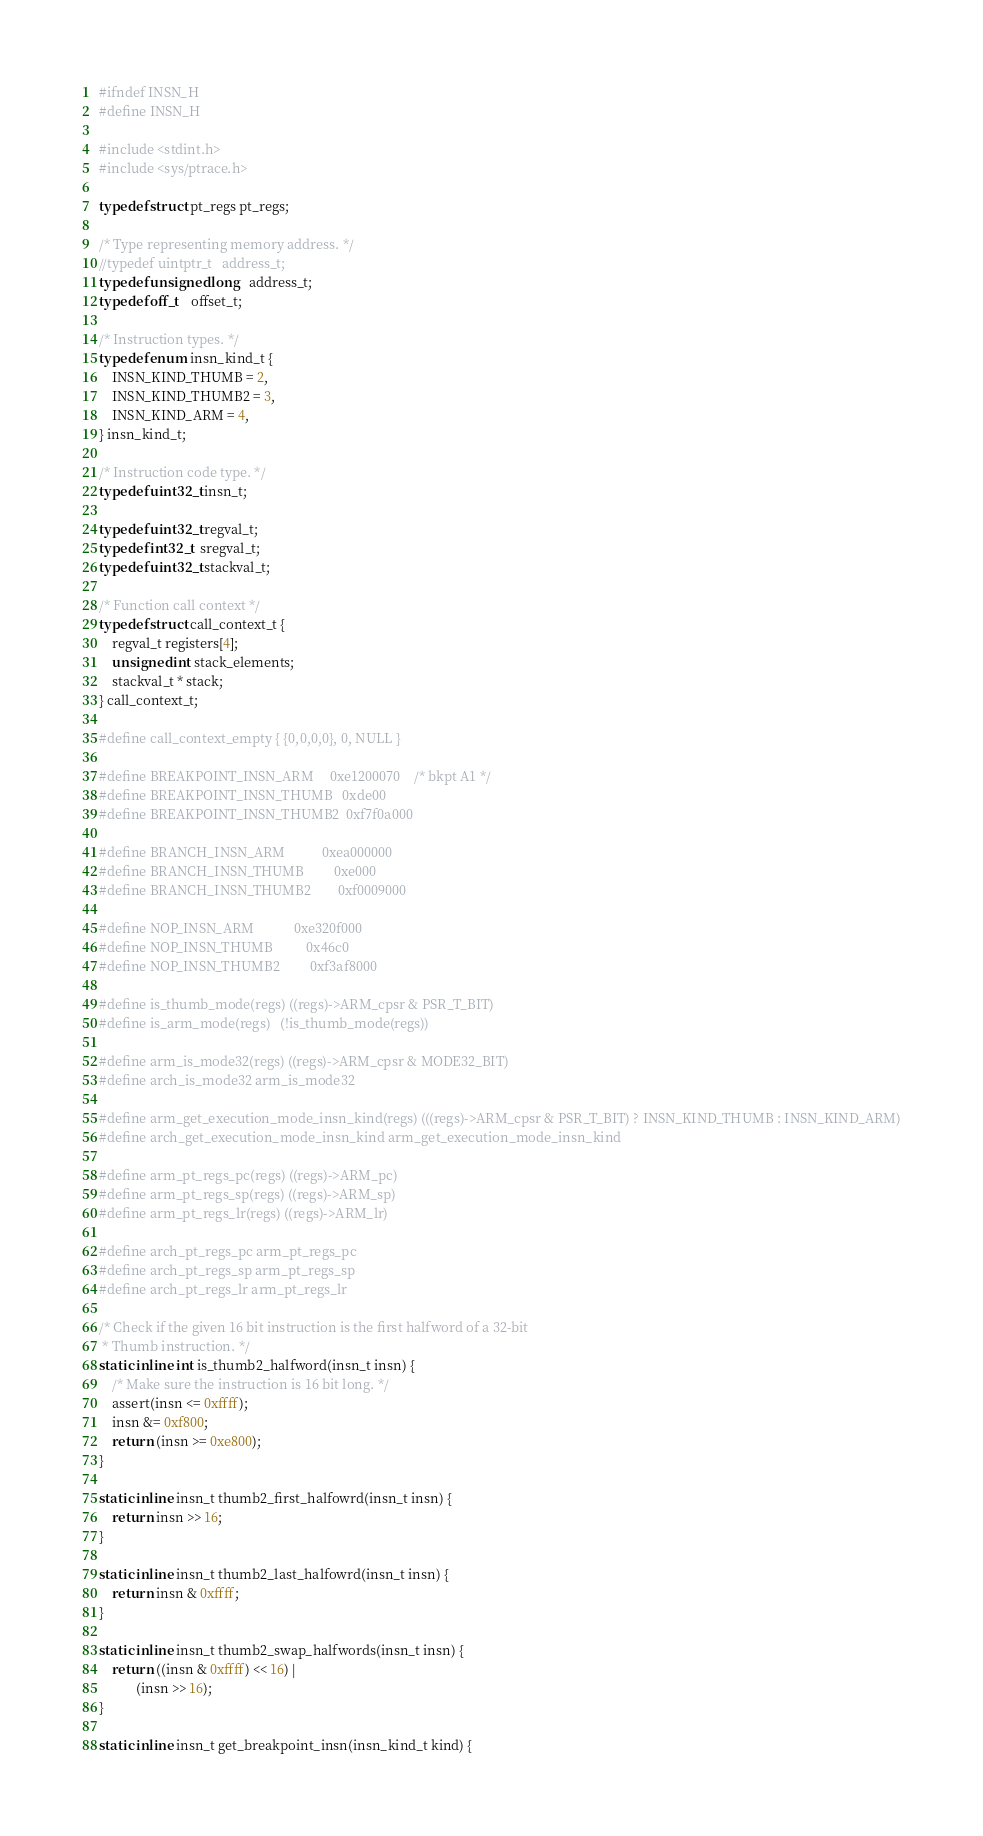<code> <loc_0><loc_0><loc_500><loc_500><_C_>#ifndef INSN_H
#define INSN_H

#include <stdint.h>
#include <sys/ptrace.h>

typedef struct pt_regs pt_regs;

/* Type representing memory address. */
//typedef uintptr_t   address_t;
typedef unsigned long   address_t;
typedef off_t    offset_t;

/* Instruction types. */
typedef enum insn_kind_t {
    INSN_KIND_THUMB = 2,
    INSN_KIND_THUMB2 = 3,
    INSN_KIND_ARM = 4,
} insn_kind_t;

/* Instruction code type. */
typedef uint32_t insn_t;

typedef uint32_t regval_t;
typedef int32_t  sregval_t;
typedef uint32_t stackval_t;

/* Function call context */
typedef struct call_context_t {
    regval_t registers[4];
    unsigned int stack_elements;
    stackval_t * stack;
} call_context_t;

#define call_context_empty { {0,0,0,0}, 0, NULL }

#define BREAKPOINT_INSN_ARM     0xe1200070    /* bkpt A1 */
#define BREAKPOINT_INSN_THUMB   0xde00
#define BREAKPOINT_INSN_THUMB2  0xf7f0a000

#define BRANCH_INSN_ARM           0xea000000
#define BRANCH_INSN_THUMB         0xe000
#define BRANCH_INSN_THUMB2        0xf0009000

#define NOP_INSN_ARM            0xe320f000
#define NOP_INSN_THUMB          0x46c0
#define NOP_INSN_THUMB2         0xf3af8000

#define is_thumb_mode(regs) ((regs)->ARM_cpsr & PSR_T_BIT)
#define is_arm_mode(regs)   (!is_thumb_mode(regs))

#define arm_is_mode32(regs) ((regs)->ARM_cpsr & MODE32_BIT)
#define arch_is_mode32 arm_is_mode32

#define arm_get_execution_mode_insn_kind(regs) (((regs)->ARM_cpsr & PSR_T_BIT) ? INSN_KIND_THUMB : INSN_KIND_ARM)
#define arch_get_execution_mode_insn_kind arm_get_execution_mode_insn_kind

#define arm_pt_regs_pc(regs) ((regs)->ARM_pc)
#define arm_pt_regs_sp(regs) ((regs)->ARM_sp)
#define arm_pt_regs_lr(regs) ((regs)->ARM_lr)

#define arch_pt_regs_pc arm_pt_regs_pc
#define arch_pt_regs_sp arm_pt_regs_sp
#define arch_pt_regs_lr arm_pt_regs_lr

/* Check if the given 16 bit instruction is the first halfword of a 32-bit
 * Thumb instruction. */
static inline int is_thumb2_halfword(insn_t insn) {
    /* Make sure the instruction is 16 bit long. */
    assert(insn <= 0xffff);
    insn &= 0xf800;
    return (insn >= 0xe800);
}

static inline insn_t thumb2_first_halfowrd(insn_t insn) {
    return insn >> 16;
}

static inline insn_t thumb2_last_halfowrd(insn_t insn) {
    return insn & 0xffff;
}

static inline insn_t thumb2_swap_halfwords(insn_t insn) {
    return ((insn & 0xffff) << 16) |
           (insn >> 16);
}

static inline insn_t get_breakpoint_insn(insn_kind_t kind) {</code> 